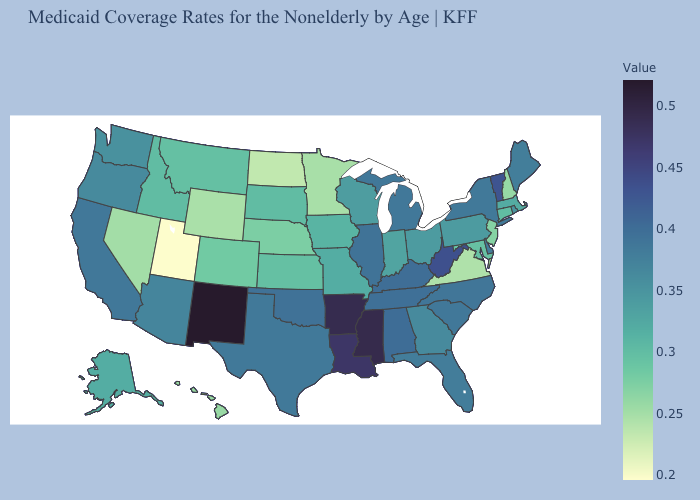Does Wisconsin have a higher value than North Dakota?
Give a very brief answer. Yes. Among the states that border New York , does Connecticut have the lowest value?
Short answer required. No. Which states hav the highest value in the MidWest?
Quick response, please. Illinois. Among the states that border West Virginia , does Maryland have the highest value?
Concise answer only. No. Is the legend a continuous bar?
Answer briefly. Yes. Among the states that border Arkansas , which have the highest value?
Give a very brief answer. Mississippi. Does Vermont have the highest value in the Northeast?
Give a very brief answer. Yes. Does New Mexico have the highest value in the USA?
Short answer required. Yes. Does Maryland have a higher value than Minnesota?
Answer briefly. Yes. 